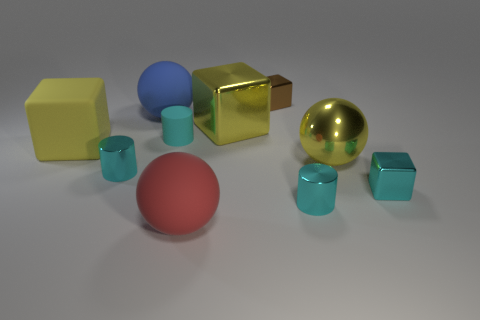Subtract all red spheres. How many yellow blocks are left? 2 Subtract all small cyan shiny cylinders. How many cylinders are left? 1 Subtract all brown blocks. How many blocks are left? 3 Subtract all purple blocks. Subtract all brown balls. How many blocks are left? 4 Subtract all blocks. How many objects are left? 6 Add 4 tiny rubber cylinders. How many tiny rubber cylinders exist? 5 Subtract 0 gray cylinders. How many objects are left? 10 Subtract all big red spheres. Subtract all matte cubes. How many objects are left? 8 Add 6 small metallic cubes. How many small metallic cubes are left? 8 